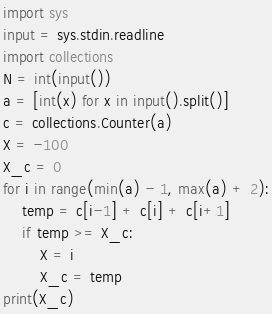Convert code to text. <code><loc_0><loc_0><loc_500><loc_500><_Python_>import sys
input = sys.stdin.readline
import collections
N = int(input())
a = [int(x) for x in input().split()]
c = collections.Counter(a)
X = -100
X_c = 0
for i in range(min(a) - 1, max(a) + 2):
    temp = c[i-1] + c[i] + c[i+1]
    if temp >= X_c:
        X = i
        X_c = temp
print(X_c)
</code> 